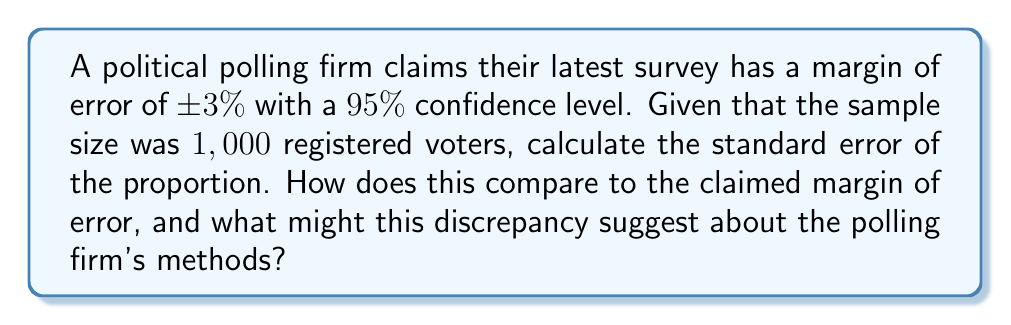Show me your answer to this math problem. Let's approach this step-by-step:

1) The standard error of a proportion is given by the formula:

   $$SE = \sqrt{\frac{p(1-p)}{n}}$$

   where $p$ is the proportion and $n$ is the sample size.

2) We don't know the actual proportion, but the maximum standard error occurs when $p = 0.5$. So, we'll use this worst-case scenario:

   $$SE = \sqrt{\frac{0.5(1-0.5)}{1000}} = \sqrt{\frac{0.25}{1000}} = 0.0158$$

3) For a 95% confidence level, the margin of error is typically calculated as:

   $$MOE = 1.96 \times SE$$

4) Using our calculated SE:

   $$MOE = 1.96 \times 0.0158 = 0.031 = 3.1\%$$

5) The polling firm claims a margin of error of ±3%, which is very close to our calculated 3.1%.

6) However, our calculation assumes the worst-case scenario ($p = 0.5$). In reality, the margin of error could be smaller.

7) The slight discrepancy might be due to:
   - Rounding (3.1% rounded down to 3%)
   - Use of a different confidence level
   - Adjustments for survey design effects

8) Given the cynical perspective of a news editor, this close match might actually raise suspicions. Are they simply applying textbook formulas without considering real-world complications like non-response bias, question wording effects, or sampling frame issues?
Answer: $SE = 0.0158$; claimed MOE consistent with calculation but may oversimplify real-world complexities. 